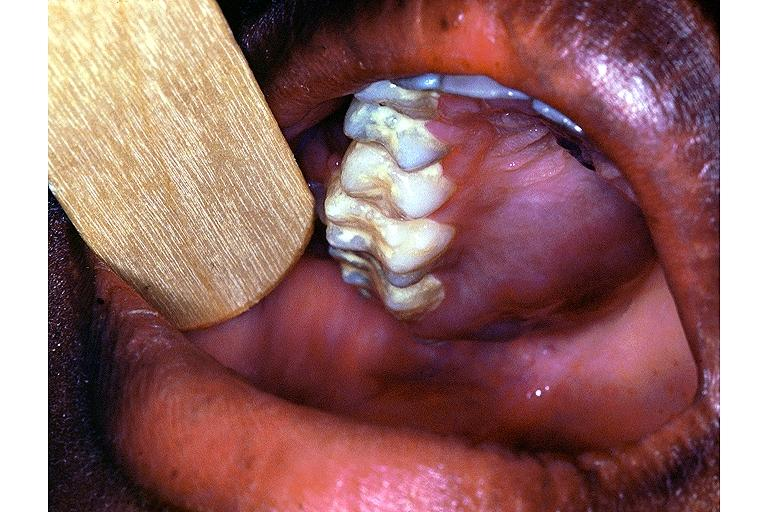does adenoma show burkit lymphoma?
Answer the question using a single word or phrase. No 